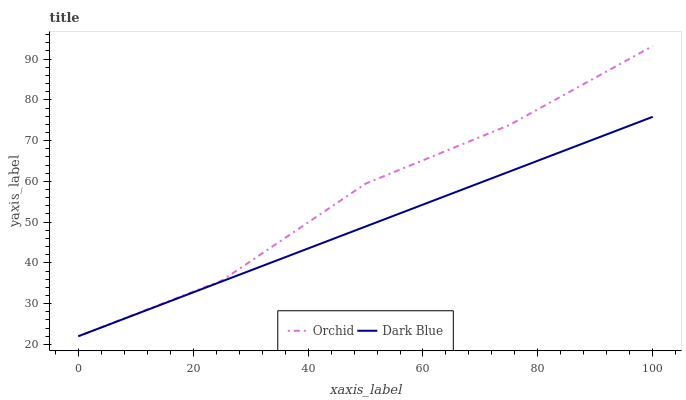Does Dark Blue have the minimum area under the curve?
Answer yes or no. Yes. Does Orchid have the maximum area under the curve?
Answer yes or no. Yes. Does Orchid have the minimum area under the curve?
Answer yes or no. No. Is Dark Blue the smoothest?
Answer yes or no. Yes. Is Orchid the roughest?
Answer yes or no. Yes. Is Orchid the smoothest?
Answer yes or no. No. Does Dark Blue have the lowest value?
Answer yes or no. Yes. Does Orchid have the highest value?
Answer yes or no. Yes. Does Dark Blue intersect Orchid?
Answer yes or no. Yes. Is Dark Blue less than Orchid?
Answer yes or no. No. Is Dark Blue greater than Orchid?
Answer yes or no. No. 